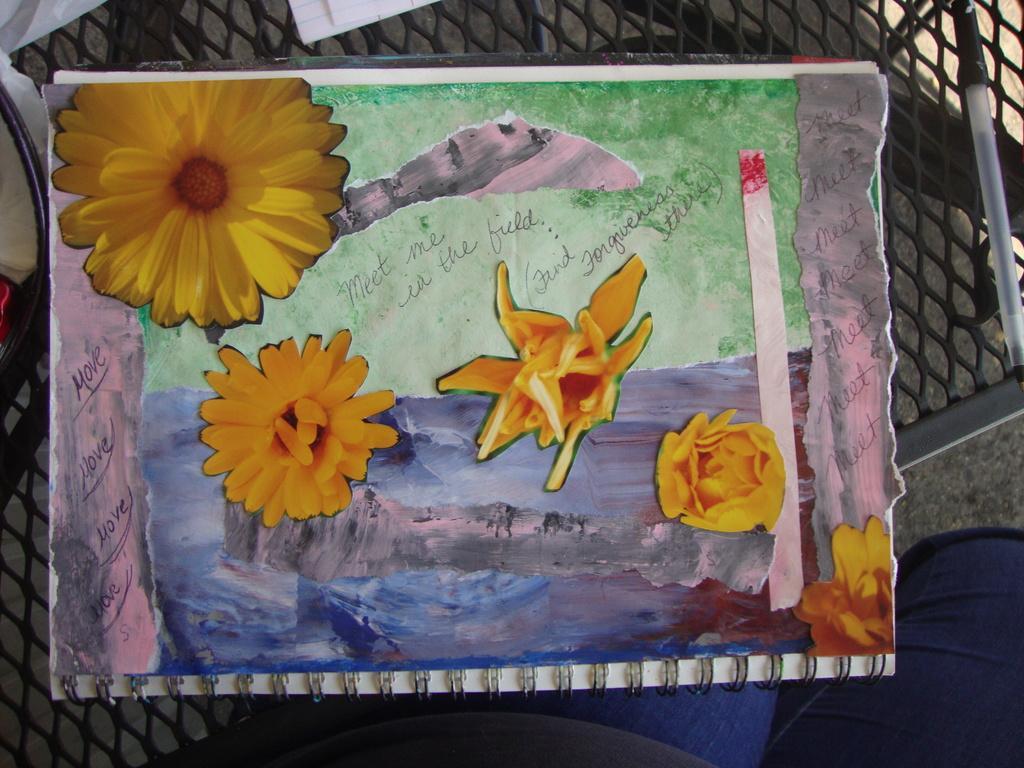Could you give a brief overview of what you see in this image? In this picture we can see a paper in the front, there is a painting of flowers and some text on the paper, on the right side there is a pen, it looks like a chair at the bottom. 